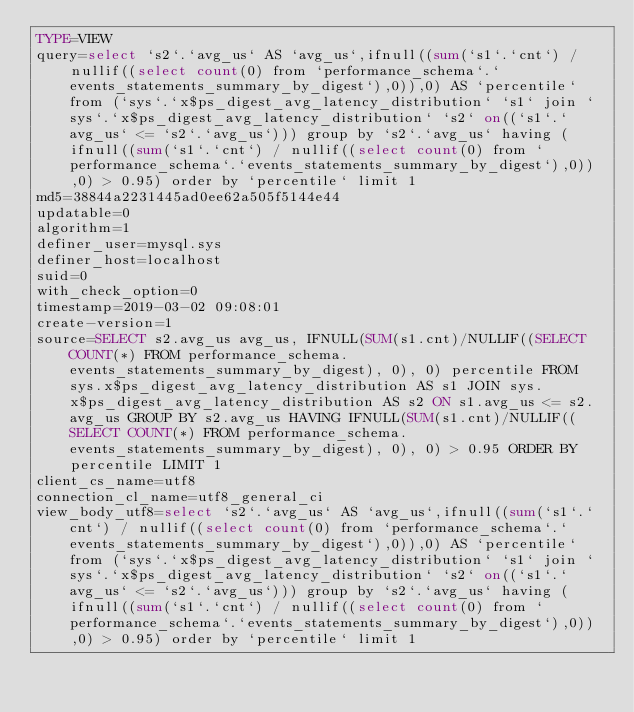<code> <loc_0><loc_0><loc_500><loc_500><_VisualBasic_>TYPE=VIEW
query=select `s2`.`avg_us` AS `avg_us`,ifnull((sum(`s1`.`cnt`) / nullif((select count(0) from `performance_schema`.`events_statements_summary_by_digest`),0)),0) AS `percentile` from (`sys`.`x$ps_digest_avg_latency_distribution` `s1` join `sys`.`x$ps_digest_avg_latency_distribution` `s2` on((`s1`.`avg_us` <= `s2`.`avg_us`))) group by `s2`.`avg_us` having (ifnull((sum(`s1`.`cnt`) / nullif((select count(0) from `performance_schema`.`events_statements_summary_by_digest`),0)),0) > 0.95) order by `percentile` limit 1
md5=38844a2231445ad0ee62a505f5144e44
updatable=0
algorithm=1
definer_user=mysql.sys
definer_host=localhost
suid=0
with_check_option=0
timestamp=2019-03-02 09:08:01
create-version=1
source=SELECT s2.avg_us avg_us, IFNULL(SUM(s1.cnt)/NULLIF((SELECT COUNT(*) FROM performance_schema.events_statements_summary_by_digest), 0), 0) percentile FROM sys.x$ps_digest_avg_latency_distribution AS s1 JOIN sys.x$ps_digest_avg_latency_distribution AS s2 ON s1.avg_us <= s2.avg_us GROUP BY s2.avg_us HAVING IFNULL(SUM(s1.cnt)/NULLIF((SELECT COUNT(*) FROM performance_schema.events_statements_summary_by_digest), 0), 0) > 0.95 ORDER BY percentile LIMIT 1
client_cs_name=utf8
connection_cl_name=utf8_general_ci
view_body_utf8=select `s2`.`avg_us` AS `avg_us`,ifnull((sum(`s1`.`cnt`) / nullif((select count(0) from `performance_schema`.`events_statements_summary_by_digest`),0)),0) AS `percentile` from (`sys`.`x$ps_digest_avg_latency_distribution` `s1` join `sys`.`x$ps_digest_avg_latency_distribution` `s2` on((`s1`.`avg_us` <= `s2`.`avg_us`))) group by `s2`.`avg_us` having (ifnull((sum(`s1`.`cnt`) / nullif((select count(0) from `performance_schema`.`events_statements_summary_by_digest`),0)),0) > 0.95) order by `percentile` limit 1
</code> 